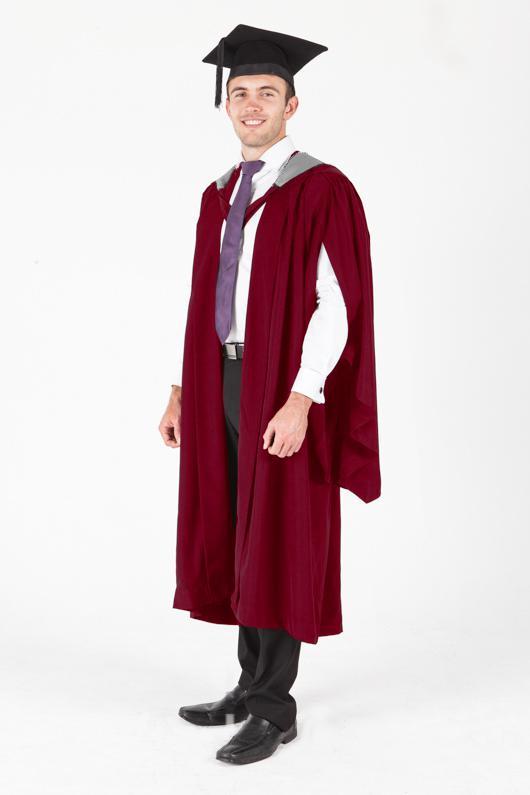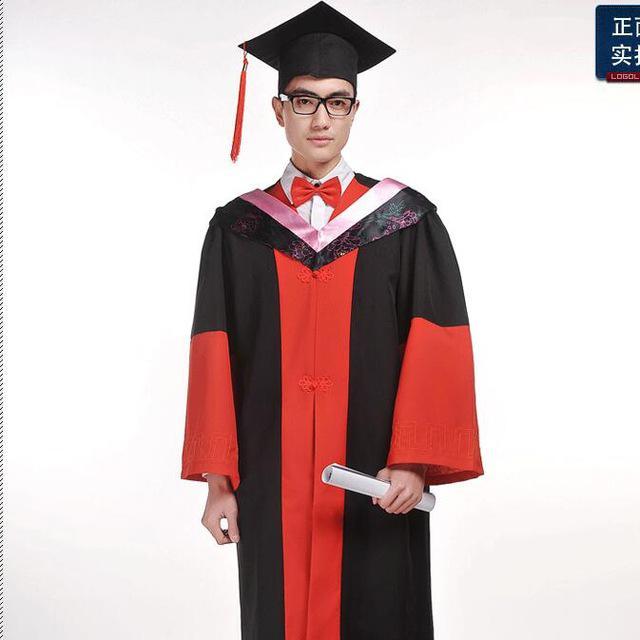The first image is the image on the left, the second image is the image on the right. Evaluate the accuracy of this statement regarding the images: "Each graduate model wears a black robe and a square-topped black hat with black tassel, but one model is a dark-haired girl and the other is a young man wearing a purple necktie.". Is it true? Answer yes or no. No. The first image is the image on the left, the second image is the image on the right. For the images shown, is this caption "The graduate attire in both images incorporate shades of red." true? Answer yes or no. Yes. 